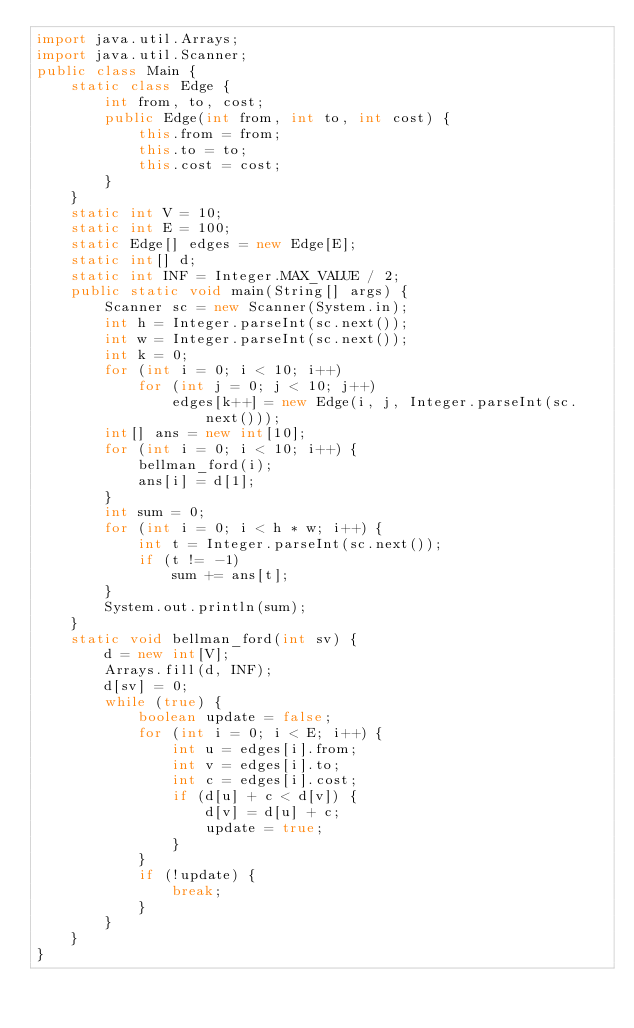Convert code to text. <code><loc_0><loc_0><loc_500><loc_500><_Java_>import java.util.Arrays;
import java.util.Scanner;
public class Main {
	static class Edge {
		int from, to, cost;
		public Edge(int from, int to, int cost) {
			this.from = from;
			this.to = to;
			this.cost = cost;
		}
	}
	static int V = 10;
	static int E = 100;
	static Edge[] edges = new Edge[E];
	static int[] d;
	static int INF = Integer.MAX_VALUE / 2;
	public static void main(String[] args) {
		Scanner sc = new Scanner(System.in);
		int h = Integer.parseInt(sc.next());
		int w = Integer.parseInt(sc.next());
		int k = 0;
		for (int i = 0; i < 10; i++)
			for (int j = 0; j < 10; j++)
				edges[k++] = new Edge(i, j, Integer.parseInt(sc.next()));
		int[] ans = new int[10];
		for (int i = 0; i < 10; i++) {
			bellman_ford(i);
			ans[i] = d[1];
		}
		int sum = 0;
		for (int i = 0; i < h * w; i++) {
			int t = Integer.parseInt(sc.next());
			if (t != -1)
				sum += ans[t];
		}
		System.out.println(sum);
	}
	static void bellman_ford(int sv) {
		d = new int[V];
		Arrays.fill(d, INF);
		d[sv] = 0;
		while (true) {
			boolean update = false;
			for (int i = 0; i < E; i++) {
				int u = edges[i].from;
				int v = edges[i].to;
				int c = edges[i].cost;
				if (d[u] + c < d[v]) {
					d[v] = d[u] + c;
					update = true;
				}
			}
			if (!update) {
				break;
			}
		}
	}
}</code> 